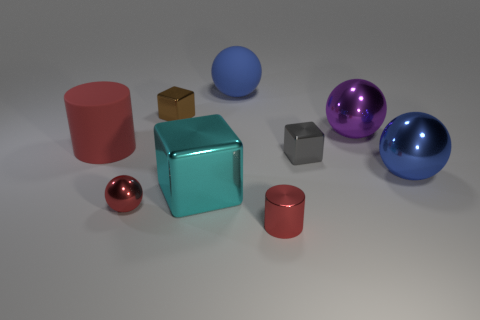Subtract all gray blocks. How many blocks are left? 2 Subtract all gray cubes. How many cubes are left? 2 Subtract all blocks. How many objects are left? 6 Add 4 blue matte balls. How many blue matte balls exist? 5 Add 1 small red metal spheres. How many objects exist? 10 Subtract 0 purple cylinders. How many objects are left? 9 Subtract 2 spheres. How many spheres are left? 2 Subtract all red balls. Subtract all cyan cylinders. How many balls are left? 3 Subtract all brown cylinders. How many yellow balls are left? 0 Subtract all big shiny things. Subtract all tiny shiny spheres. How many objects are left? 5 